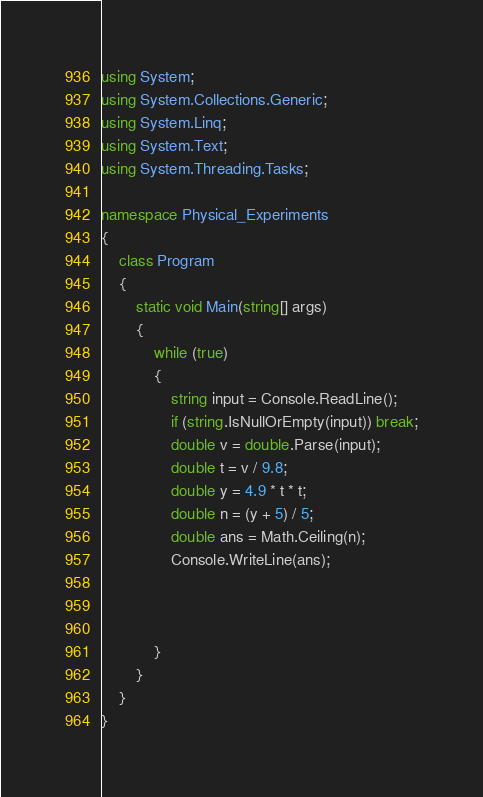Convert code to text. <code><loc_0><loc_0><loc_500><loc_500><_C#_>using System;
using System.Collections.Generic;
using System.Linq;
using System.Text;
using System.Threading.Tasks;

namespace Physical_Experiments
{
    class Program
    {
        static void Main(string[] args)
        {
            while (true)
            {
                string input = Console.ReadLine();
                if (string.IsNullOrEmpty(input)) break;
                double v = double.Parse(input);
                double t = v / 9.8;
                double y = 4.9 * t * t;
                double n = (y + 5) / 5;
                double ans = Math.Ceiling(n);
                Console.WriteLine(ans);



            }
        }
    }
}

</code> 